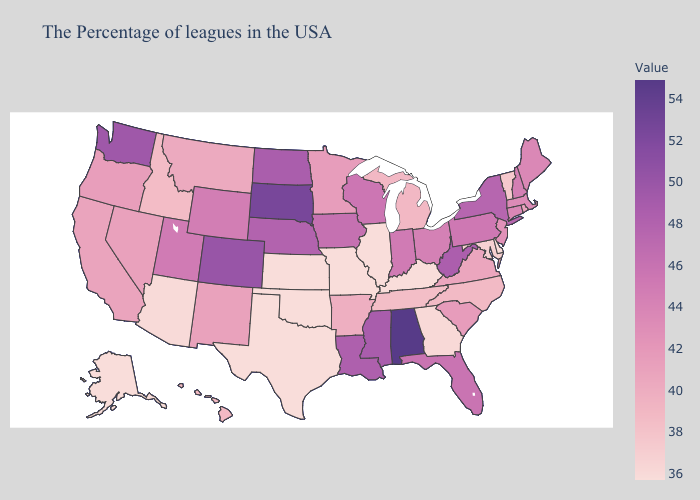Which states have the lowest value in the South?
Short answer required. Delaware, Kentucky, Oklahoma, Texas. Does Oregon have a higher value than New York?
Be succinct. No. Among the states that border Maryland , does Delaware have the lowest value?
Write a very short answer. Yes. Among the states that border Connecticut , does Massachusetts have the highest value?
Answer briefly. No. Does Kentucky have the lowest value in the USA?
Keep it brief. Yes. Among the states that border Wisconsin , which have the lowest value?
Keep it brief. Illinois. 